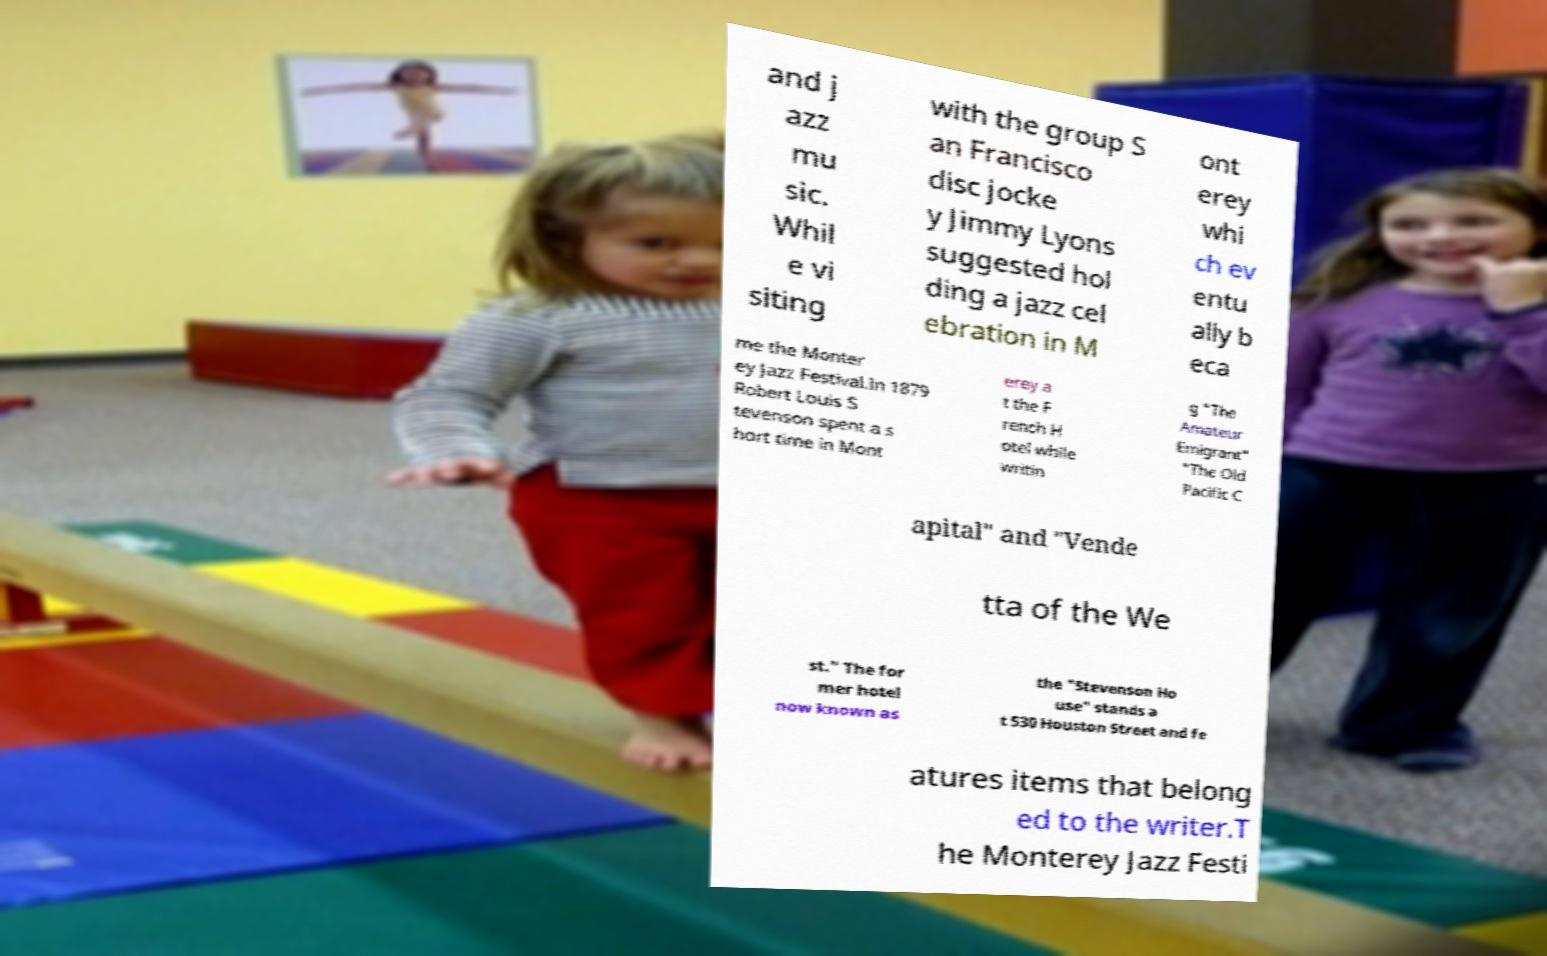What messages or text are displayed in this image? I need them in a readable, typed format. and j azz mu sic. Whil e vi siting with the group S an Francisco disc jocke y Jimmy Lyons suggested hol ding a jazz cel ebration in M ont erey whi ch ev entu ally b eca me the Monter ey Jazz Festival.In 1879 Robert Louis S tevenson spent a s hort time in Mont erey a t the F rench H otel while writin g "The Amateur Emigrant" "The Old Pacific C apital" and "Vende tta of the We st." The for mer hotel now known as the "Stevenson Ho use" stands a t 530 Houston Street and fe atures items that belong ed to the writer.T he Monterey Jazz Festi 